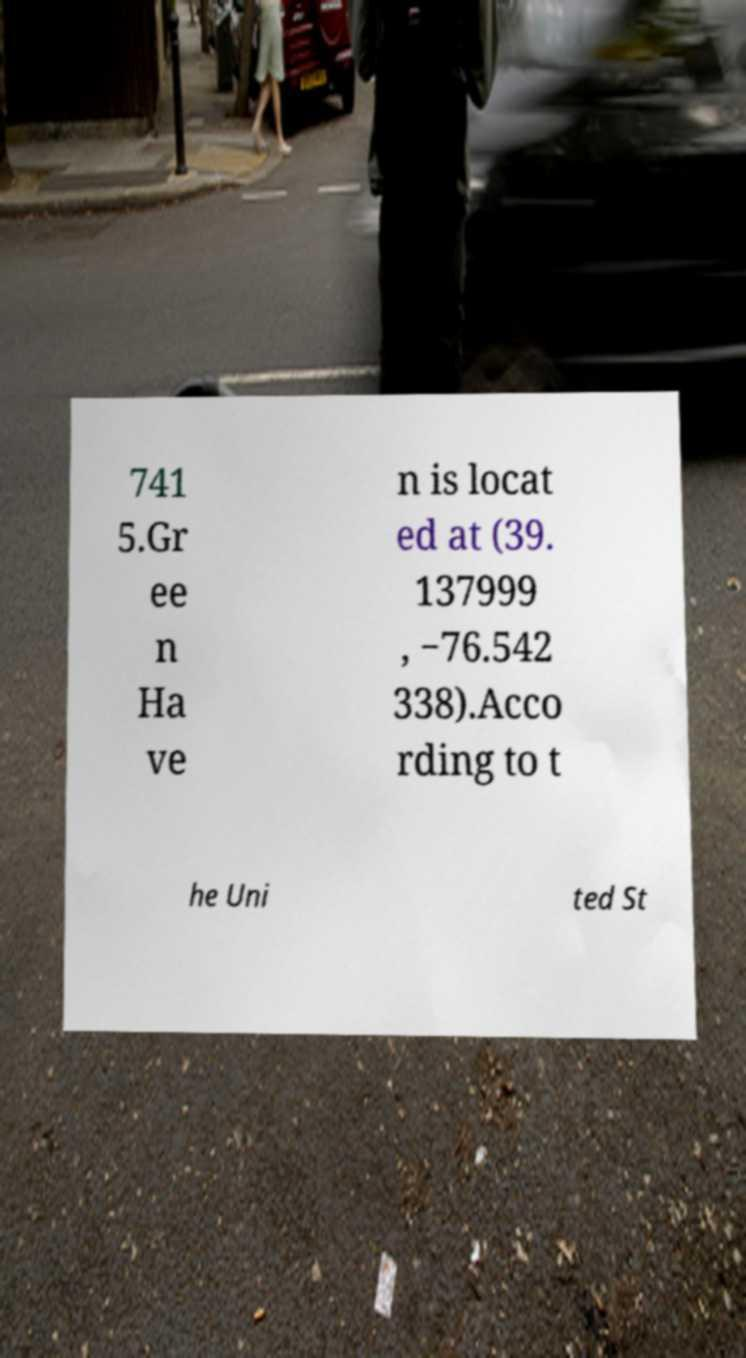Can you accurately transcribe the text from the provided image for me? 741 5.Gr ee n Ha ve n is locat ed at (39. 137999 , −76.542 338).Acco rding to t he Uni ted St 